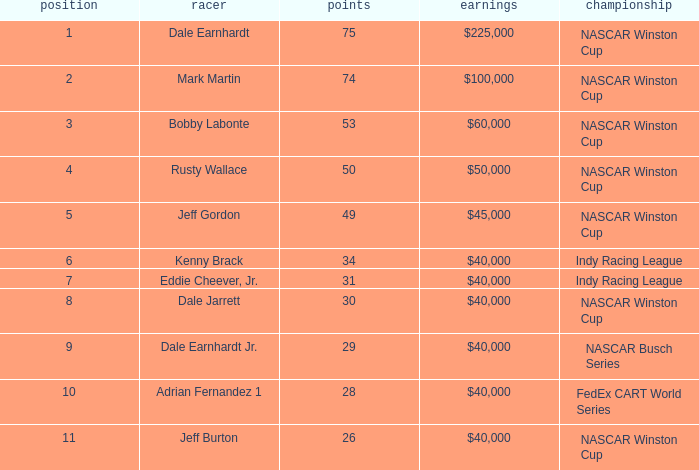In what position was the driver who won $60,000? 3.0. 